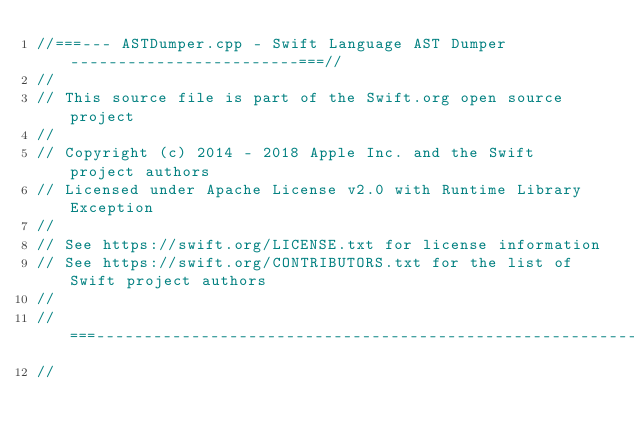<code> <loc_0><loc_0><loc_500><loc_500><_C++_>//===--- ASTDumper.cpp - Swift Language AST Dumper ------------------------===//
//
// This source file is part of the Swift.org open source project
//
// Copyright (c) 2014 - 2018 Apple Inc. and the Swift project authors
// Licensed under Apache License v2.0 with Runtime Library Exception
//
// See https://swift.org/LICENSE.txt for license information
// See https://swift.org/CONTRIBUTORS.txt for the list of Swift project authors
//
//===----------------------------------------------------------------------===//
//</code> 